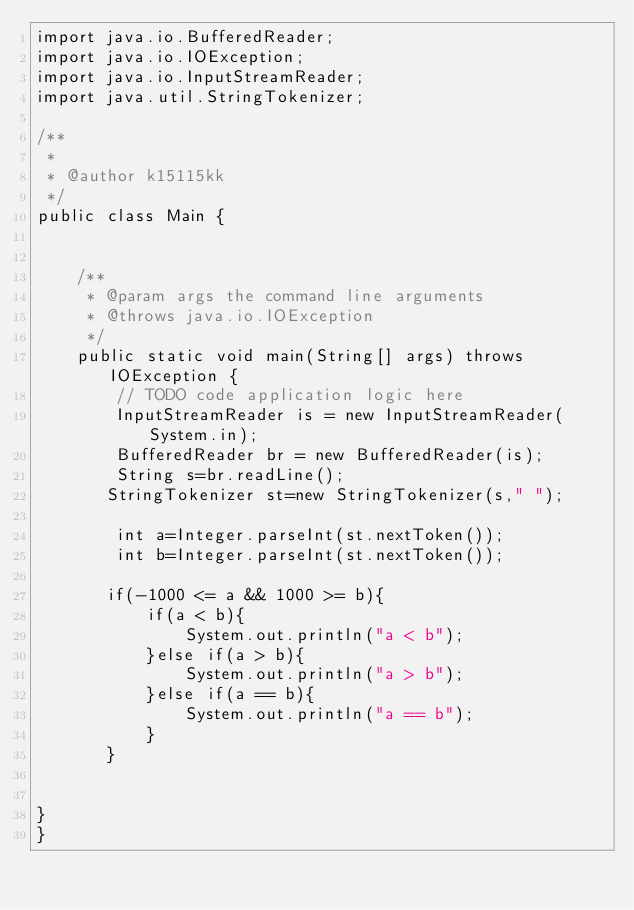Convert code to text. <code><loc_0><loc_0><loc_500><loc_500><_Java_>import java.io.BufferedReader;
import java.io.IOException;
import java.io.InputStreamReader;
import java.util.StringTokenizer;

/**
 *
 * @author k15115kk
 */
public class Main {

    
    /**
     * @param args the command line arguments
     * @throws java.io.IOException
     */
    public static void main(String[] args) throws IOException {
        // TODO code application logic here
        InputStreamReader is = new InputStreamReader(System.in);       
        BufferedReader br = new BufferedReader(is);
        String s=br.readLine();
       StringTokenizer st=new StringTokenizer(s," ");
         
        int a=Integer.parseInt(st.nextToken());
        int b=Integer.parseInt(st.nextToken());
        
       if(-1000 <= a && 1000 >= b){
           if(a < b){
               System.out.println("a < b");
           }else if(a > b){
               System.out.println("a > b");
           }else if(a == b){
               System.out.println("a == b");
           }
       }
     
    
}
}</code> 